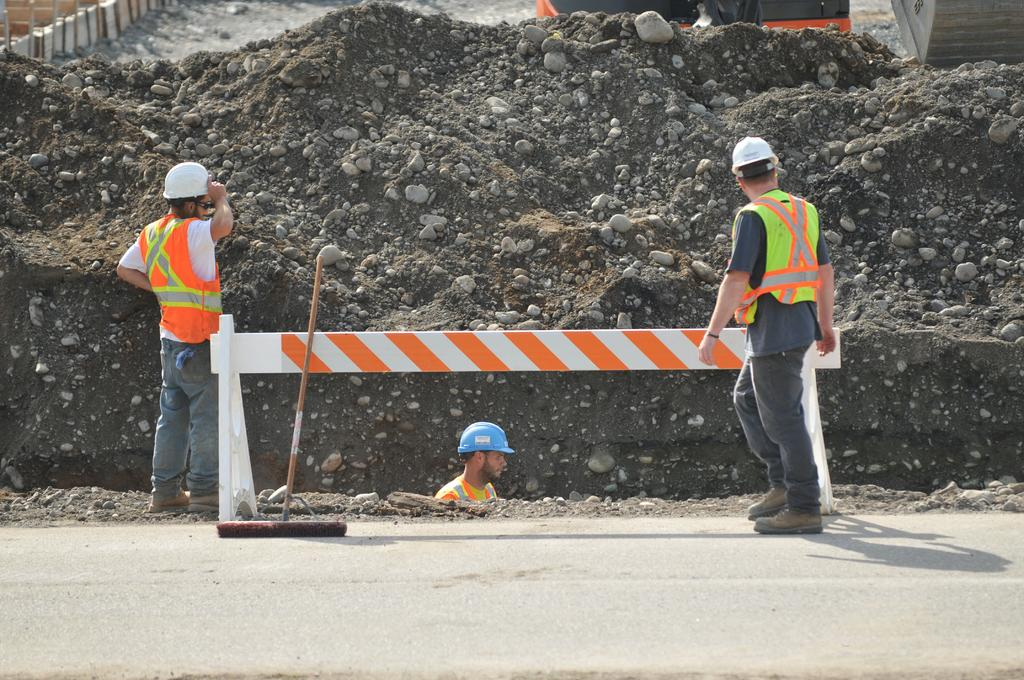What are the people in the image doing? There are people standing on a road in the image. What activity is being performed by one of the people in the image? There is a person digging soil in the image. What type of terrain can be seen in the background of the image? There is soil and stones visible in the background of the image. What safety measure is present in the background of the image? There is a caution board in the background of the image. What type of learning is taking place in the image? There is no indication of learning taking place in the image; it primarily shows people standing on a road and one person digging soil. How does the discovery of a new species relate to the image? There is no mention of a new species or any discovery in the image; it focuses on people and their activities on a road and in the soil. 